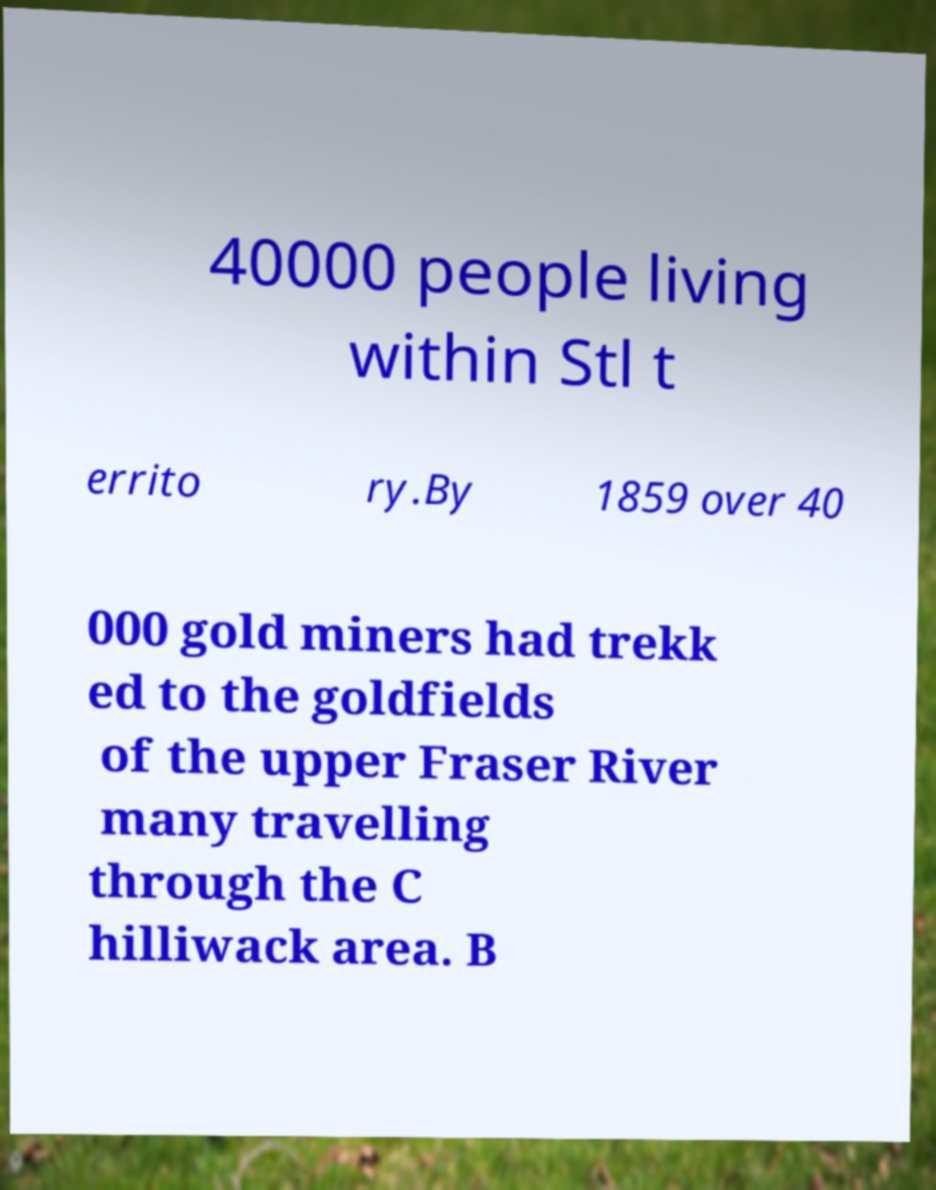Please identify and transcribe the text found in this image. 40000 people living within Stl t errito ry.By 1859 over 40 000 gold miners had trekk ed to the goldfields of the upper Fraser River many travelling through the C hilliwack area. B 